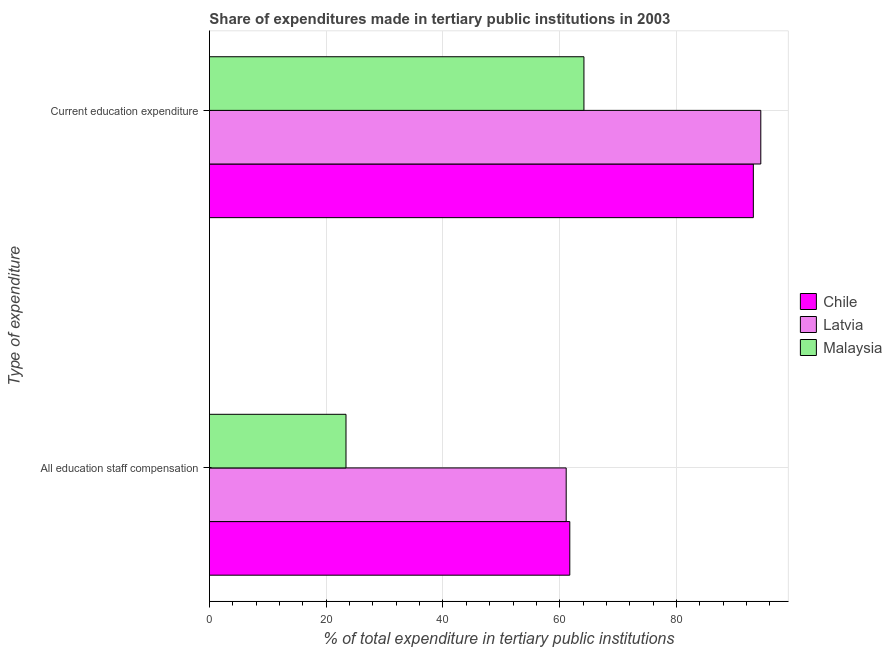How many groups of bars are there?
Your response must be concise. 2. Are the number of bars on each tick of the Y-axis equal?
Keep it short and to the point. Yes. How many bars are there on the 1st tick from the bottom?
Your answer should be compact. 3. What is the label of the 2nd group of bars from the top?
Ensure brevity in your answer.  All education staff compensation. What is the expenditure in education in Latvia?
Make the answer very short. 94.44. Across all countries, what is the maximum expenditure in education?
Ensure brevity in your answer.  94.44. Across all countries, what is the minimum expenditure in staff compensation?
Offer a terse response. 23.4. In which country was the expenditure in education maximum?
Your answer should be very brief. Latvia. In which country was the expenditure in education minimum?
Make the answer very short. Malaysia. What is the total expenditure in education in the graph?
Ensure brevity in your answer.  251.76. What is the difference between the expenditure in staff compensation in Chile and that in Malaysia?
Offer a very short reply. 38.33. What is the difference between the expenditure in staff compensation in Chile and the expenditure in education in Latvia?
Ensure brevity in your answer.  -32.72. What is the average expenditure in staff compensation per country?
Your response must be concise. 48.74. What is the difference between the expenditure in education and expenditure in staff compensation in Chile?
Offer a very short reply. 31.44. What is the ratio of the expenditure in staff compensation in Latvia to that in Malaysia?
Give a very brief answer. 2.61. Is the expenditure in education in Malaysia less than that in Chile?
Offer a very short reply. Yes. In how many countries, is the expenditure in education greater than the average expenditure in education taken over all countries?
Provide a short and direct response. 2. What does the 1st bar from the bottom in Current education expenditure represents?
Offer a very short reply. Chile. How many bars are there?
Offer a terse response. 6. How many countries are there in the graph?
Provide a short and direct response. 3. What is the difference between two consecutive major ticks on the X-axis?
Your answer should be very brief. 20. Are the values on the major ticks of X-axis written in scientific E-notation?
Offer a terse response. No. Does the graph contain any zero values?
Offer a terse response. No. Does the graph contain grids?
Offer a very short reply. Yes. How many legend labels are there?
Your response must be concise. 3. How are the legend labels stacked?
Your response must be concise. Vertical. What is the title of the graph?
Offer a very short reply. Share of expenditures made in tertiary public institutions in 2003. Does "Mexico" appear as one of the legend labels in the graph?
Offer a terse response. No. What is the label or title of the X-axis?
Offer a very short reply. % of total expenditure in tertiary public institutions. What is the label or title of the Y-axis?
Offer a terse response. Type of expenditure. What is the % of total expenditure in tertiary public institutions in Chile in All education staff compensation?
Your response must be concise. 61.73. What is the % of total expenditure in tertiary public institutions in Latvia in All education staff compensation?
Offer a very short reply. 61.11. What is the % of total expenditure in tertiary public institutions in Malaysia in All education staff compensation?
Ensure brevity in your answer.  23.4. What is the % of total expenditure in tertiary public institutions of Chile in Current education expenditure?
Make the answer very short. 93.17. What is the % of total expenditure in tertiary public institutions of Latvia in Current education expenditure?
Keep it short and to the point. 94.44. What is the % of total expenditure in tertiary public institutions of Malaysia in Current education expenditure?
Your answer should be compact. 64.15. Across all Type of expenditure, what is the maximum % of total expenditure in tertiary public institutions in Chile?
Ensure brevity in your answer.  93.17. Across all Type of expenditure, what is the maximum % of total expenditure in tertiary public institutions of Latvia?
Make the answer very short. 94.44. Across all Type of expenditure, what is the maximum % of total expenditure in tertiary public institutions of Malaysia?
Make the answer very short. 64.15. Across all Type of expenditure, what is the minimum % of total expenditure in tertiary public institutions in Chile?
Offer a terse response. 61.73. Across all Type of expenditure, what is the minimum % of total expenditure in tertiary public institutions in Latvia?
Your response must be concise. 61.11. Across all Type of expenditure, what is the minimum % of total expenditure in tertiary public institutions in Malaysia?
Make the answer very short. 23.4. What is the total % of total expenditure in tertiary public institutions in Chile in the graph?
Give a very brief answer. 154.9. What is the total % of total expenditure in tertiary public institutions in Latvia in the graph?
Offer a very short reply. 155.56. What is the total % of total expenditure in tertiary public institutions of Malaysia in the graph?
Your response must be concise. 87.55. What is the difference between the % of total expenditure in tertiary public institutions in Chile in All education staff compensation and that in Current education expenditure?
Offer a very short reply. -31.44. What is the difference between the % of total expenditure in tertiary public institutions of Latvia in All education staff compensation and that in Current education expenditure?
Ensure brevity in your answer.  -33.33. What is the difference between the % of total expenditure in tertiary public institutions in Malaysia in All education staff compensation and that in Current education expenditure?
Make the answer very short. -40.76. What is the difference between the % of total expenditure in tertiary public institutions of Chile in All education staff compensation and the % of total expenditure in tertiary public institutions of Latvia in Current education expenditure?
Ensure brevity in your answer.  -32.72. What is the difference between the % of total expenditure in tertiary public institutions in Chile in All education staff compensation and the % of total expenditure in tertiary public institutions in Malaysia in Current education expenditure?
Offer a terse response. -2.42. What is the difference between the % of total expenditure in tertiary public institutions of Latvia in All education staff compensation and the % of total expenditure in tertiary public institutions of Malaysia in Current education expenditure?
Provide a succinct answer. -3.04. What is the average % of total expenditure in tertiary public institutions in Chile per Type of expenditure?
Offer a very short reply. 77.45. What is the average % of total expenditure in tertiary public institutions of Latvia per Type of expenditure?
Make the answer very short. 77.78. What is the average % of total expenditure in tertiary public institutions in Malaysia per Type of expenditure?
Your answer should be very brief. 43.77. What is the difference between the % of total expenditure in tertiary public institutions of Chile and % of total expenditure in tertiary public institutions of Latvia in All education staff compensation?
Give a very brief answer. 0.62. What is the difference between the % of total expenditure in tertiary public institutions of Chile and % of total expenditure in tertiary public institutions of Malaysia in All education staff compensation?
Offer a terse response. 38.33. What is the difference between the % of total expenditure in tertiary public institutions of Latvia and % of total expenditure in tertiary public institutions of Malaysia in All education staff compensation?
Your answer should be compact. 37.72. What is the difference between the % of total expenditure in tertiary public institutions of Chile and % of total expenditure in tertiary public institutions of Latvia in Current education expenditure?
Offer a terse response. -1.28. What is the difference between the % of total expenditure in tertiary public institutions of Chile and % of total expenditure in tertiary public institutions of Malaysia in Current education expenditure?
Provide a short and direct response. 29.02. What is the difference between the % of total expenditure in tertiary public institutions in Latvia and % of total expenditure in tertiary public institutions in Malaysia in Current education expenditure?
Make the answer very short. 30.29. What is the ratio of the % of total expenditure in tertiary public institutions in Chile in All education staff compensation to that in Current education expenditure?
Your answer should be very brief. 0.66. What is the ratio of the % of total expenditure in tertiary public institutions of Latvia in All education staff compensation to that in Current education expenditure?
Keep it short and to the point. 0.65. What is the ratio of the % of total expenditure in tertiary public institutions of Malaysia in All education staff compensation to that in Current education expenditure?
Provide a short and direct response. 0.36. What is the difference between the highest and the second highest % of total expenditure in tertiary public institutions in Chile?
Your response must be concise. 31.44. What is the difference between the highest and the second highest % of total expenditure in tertiary public institutions in Latvia?
Offer a very short reply. 33.33. What is the difference between the highest and the second highest % of total expenditure in tertiary public institutions of Malaysia?
Your answer should be very brief. 40.76. What is the difference between the highest and the lowest % of total expenditure in tertiary public institutions in Chile?
Your answer should be compact. 31.44. What is the difference between the highest and the lowest % of total expenditure in tertiary public institutions of Latvia?
Make the answer very short. 33.33. What is the difference between the highest and the lowest % of total expenditure in tertiary public institutions in Malaysia?
Provide a succinct answer. 40.76. 